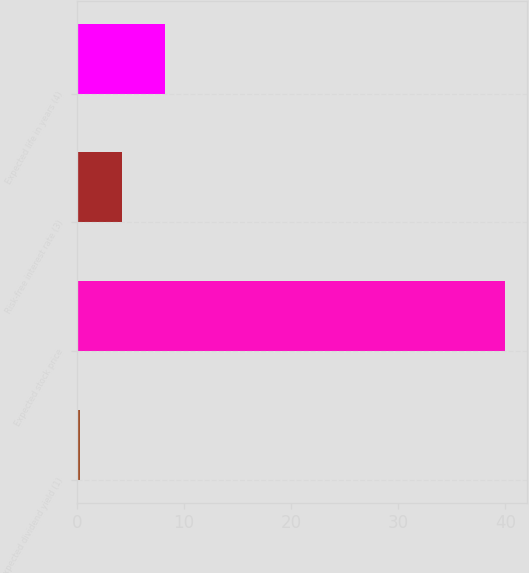<chart> <loc_0><loc_0><loc_500><loc_500><bar_chart><fcel>Expected dividend yield (1)<fcel>Expected stock price<fcel>Risk-free interest rate (3)<fcel>Expected life in years (4)<nl><fcel>0.27<fcel>40<fcel>4.24<fcel>8.21<nl></chart> 